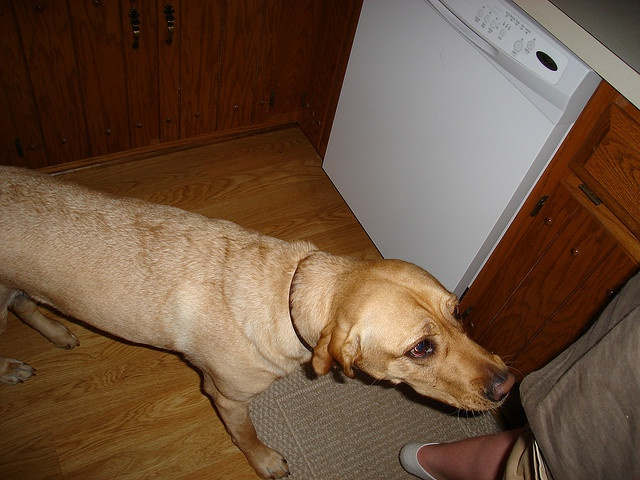Describe the objects in this image and their specific colors. I can see dog in black, tan, gray, and maroon tones and people in black, gray, and maroon tones in this image. 